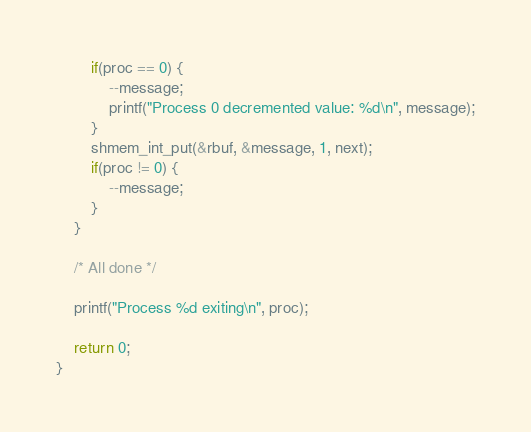<code> <loc_0><loc_0><loc_500><loc_500><_C_>        if(proc == 0) {
            --message;
            printf("Process 0 decremented value: %d\n", message);
        }
        shmem_int_put(&rbuf, &message, 1, next);
        if(proc != 0) {
            --message;
        }
    }

    /* All done */

    printf("Process %d exiting\n", proc);

    return 0;
}
</code> 